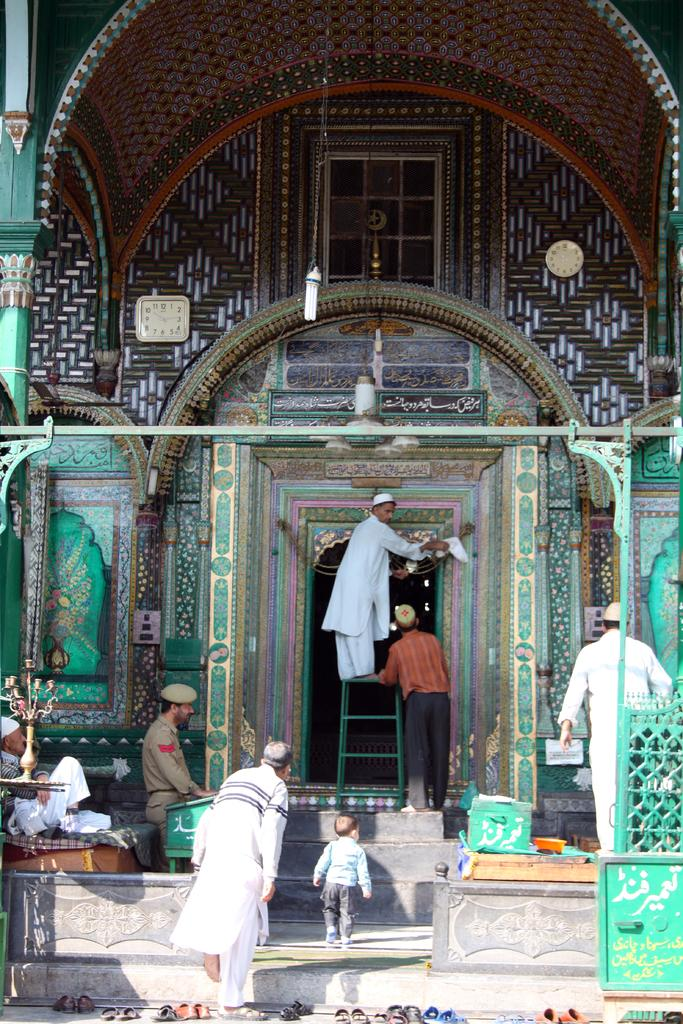Who or what can be seen in the image? There are people in the image. What object is present that can be used for climbing or reaching higher places? There is a ladder in the image. What type of structure is visible in the image? There is a building in the image. What time-telling devices are present in the image? There are clocks in the image. What type of footwear can be seen in the image? There are foot wears in the image. What architectural feature is present in the image that allows for movement between different levels? There are steps in the image. Where are the chickens kept in the image? There are no chickens present in the image. What type of pie can be seen on the table in the image? There is no pie present in the image. 